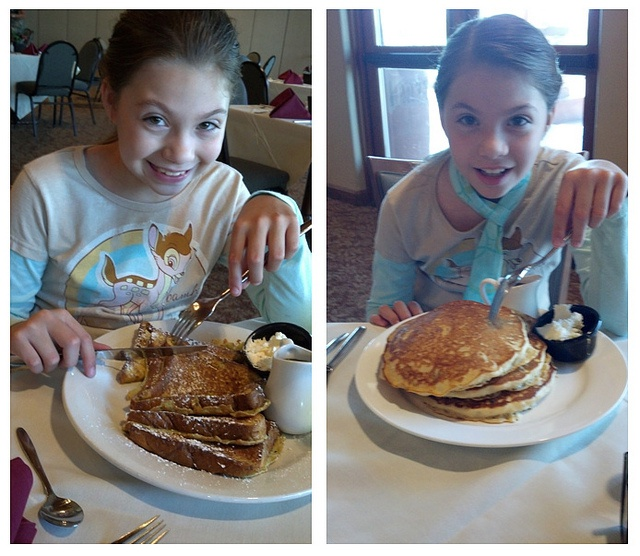Describe the objects in this image and their specific colors. I can see dining table in white, darkgray, gray, lightgray, and tan tones, people in white, gray, darkgray, and black tones, dining table in white, darkgray, maroon, and gray tones, people in white, gray, and darkgray tones, and sandwich in white, maroon, black, and gray tones in this image. 